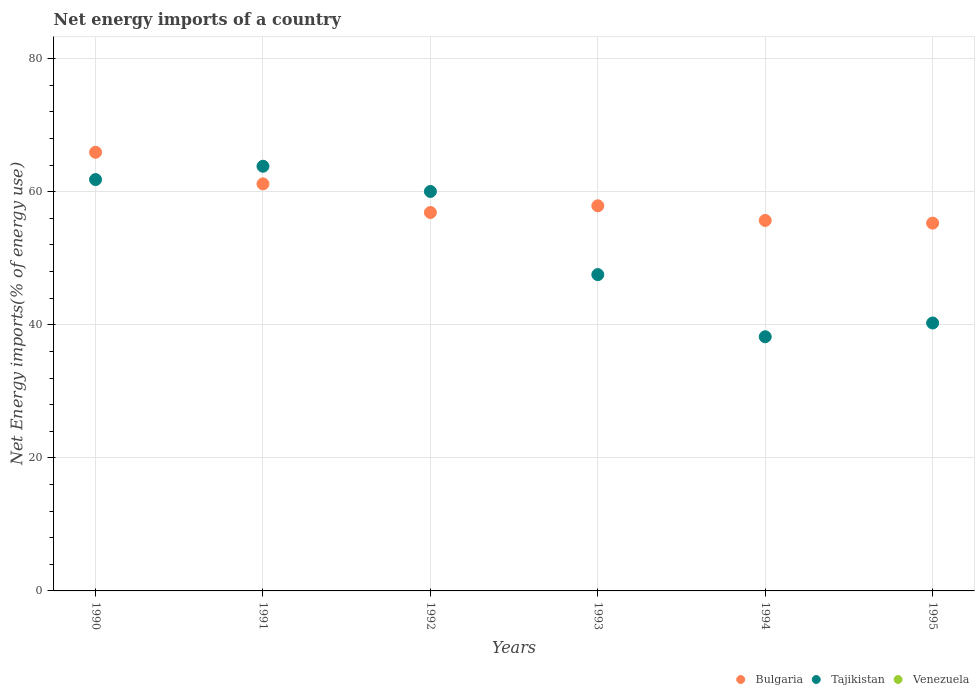How many different coloured dotlines are there?
Keep it short and to the point. 2. Is the number of dotlines equal to the number of legend labels?
Make the answer very short. No. What is the net energy imports in Bulgaria in 1994?
Offer a terse response. 55.69. Across all years, what is the maximum net energy imports in Tajikistan?
Provide a short and direct response. 63.84. Across all years, what is the minimum net energy imports in Bulgaria?
Offer a very short reply. 55.29. In which year was the net energy imports in Bulgaria maximum?
Make the answer very short. 1990. What is the total net energy imports in Tajikistan in the graph?
Provide a succinct answer. 311.75. What is the difference between the net energy imports in Tajikistan in 1992 and that in 1993?
Provide a short and direct response. 12.5. What is the difference between the net energy imports in Tajikistan in 1995 and the net energy imports in Bulgaria in 1990?
Keep it short and to the point. -25.66. What is the average net energy imports in Venezuela per year?
Ensure brevity in your answer.  0. In the year 1993, what is the difference between the net energy imports in Bulgaria and net energy imports in Tajikistan?
Offer a very short reply. 10.34. In how many years, is the net energy imports in Bulgaria greater than 44 %?
Keep it short and to the point. 6. What is the ratio of the net energy imports in Tajikistan in 1990 to that in 1993?
Offer a terse response. 1.3. Is the net energy imports in Tajikistan in 1990 less than that in 1995?
Offer a very short reply. No. What is the difference between the highest and the second highest net energy imports in Bulgaria?
Provide a short and direct response. 4.75. What is the difference between the highest and the lowest net energy imports in Tajikistan?
Your answer should be very brief. 25.63. Is the sum of the net energy imports in Tajikistan in 1991 and 1994 greater than the maximum net energy imports in Bulgaria across all years?
Provide a succinct answer. Yes. Does the net energy imports in Bulgaria monotonically increase over the years?
Provide a short and direct response. No. Is the net energy imports in Bulgaria strictly greater than the net energy imports in Tajikistan over the years?
Offer a terse response. No. How many dotlines are there?
Your answer should be very brief. 2. How many years are there in the graph?
Offer a terse response. 6. What is the difference between two consecutive major ticks on the Y-axis?
Make the answer very short. 20. Are the values on the major ticks of Y-axis written in scientific E-notation?
Give a very brief answer. No. Where does the legend appear in the graph?
Make the answer very short. Bottom right. What is the title of the graph?
Give a very brief answer. Net energy imports of a country. What is the label or title of the Y-axis?
Make the answer very short. Net Energy imports(% of energy use). What is the Net Energy imports(% of energy use) in Bulgaria in 1990?
Provide a succinct answer. 65.94. What is the Net Energy imports(% of energy use) in Tajikistan in 1990?
Offer a terse response. 61.84. What is the Net Energy imports(% of energy use) of Venezuela in 1990?
Give a very brief answer. 0. What is the Net Energy imports(% of energy use) of Bulgaria in 1991?
Provide a succinct answer. 61.19. What is the Net Energy imports(% of energy use) of Tajikistan in 1991?
Provide a short and direct response. 63.84. What is the Net Energy imports(% of energy use) in Bulgaria in 1992?
Provide a short and direct response. 56.88. What is the Net Energy imports(% of energy use) in Tajikistan in 1992?
Provide a succinct answer. 60.05. What is the Net Energy imports(% of energy use) in Bulgaria in 1993?
Ensure brevity in your answer.  57.89. What is the Net Energy imports(% of energy use) of Tajikistan in 1993?
Ensure brevity in your answer.  47.55. What is the Net Energy imports(% of energy use) in Bulgaria in 1994?
Your answer should be very brief. 55.69. What is the Net Energy imports(% of energy use) in Tajikistan in 1994?
Offer a terse response. 38.21. What is the Net Energy imports(% of energy use) of Venezuela in 1994?
Your answer should be very brief. 0. What is the Net Energy imports(% of energy use) of Bulgaria in 1995?
Give a very brief answer. 55.29. What is the Net Energy imports(% of energy use) of Tajikistan in 1995?
Your answer should be very brief. 40.28. Across all years, what is the maximum Net Energy imports(% of energy use) in Bulgaria?
Offer a terse response. 65.94. Across all years, what is the maximum Net Energy imports(% of energy use) of Tajikistan?
Your answer should be compact. 63.84. Across all years, what is the minimum Net Energy imports(% of energy use) of Bulgaria?
Your answer should be compact. 55.29. Across all years, what is the minimum Net Energy imports(% of energy use) in Tajikistan?
Offer a terse response. 38.21. What is the total Net Energy imports(% of energy use) in Bulgaria in the graph?
Offer a terse response. 352.88. What is the total Net Energy imports(% of energy use) of Tajikistan in the graph?
Your answer should be very brief. 311.75. What is the difference between the Net Energy imports(% of energy use) in Bulgaria in 1990 and that in 1991?
Provide a succinct answer. 4.75. What is the difference between the Net Energy imports(% of energy use) in Tajikistan in 1990 and that in 1991?
Your answer should be very brief. -2. What is the difference between the Net Energy imports(% of energy use) of Bulgaria in 1990 and that in 1992?
Ensure brevity in your answer.  9.05. What is the difference between the Net Energy imports(% of energy use) in Tajikistan in 1990 and that in 1992?
Your answer should be very brief. 1.79. What is the difference between the Net Energy imports(% of energy use) of Bulgaria in 1990 and that in 1993?
Make the answer very short. 8.05. What is the difference between the Net Energy imports(% of energy use) in Tajikistan in 1990 and that in 1993?
Your answer should be very brief. 14.29. What is the difference between the Net Energy imports(% of energy use) of Bulgaria in 1990 and that in 1994?
Offer a terse response. 10.25. What is the difference between the Net Energy imports(% of energy use) of Tajikistan in 1990 and that in 1994?
Make the answer very short. 23.63. What is the difference between the Net Energy imports(% of energy use) in Bulgaria in 1990 and that in 1995?
Give a very brief answer. 10.65. What is the difference between the Net Energy imports(% of energy use) in Tajikistan in 1990 and that in 1995?
Offer a very short reply. 21.56. What is the difference between the Net Energy imports(% of energy use) in Bulgaria in 1991 and that in 1992?
Keep it short and to the point. 4.3. What is the difference between the Net Energy imports(% of energy use) of Tajikistan in 1991 and that in 1992?
Your answer should be compact. 3.79. What is the difference between the Net Energy imports(% of energy use) in Bulgaria in 1991 and that in 1993?
Keep it short and to the point. 3.3. What is the difference between the Net Energy imports(% of energy use) in Tajikistan in 1991 and that in 1993?
Provide a succinct answer. 16.29. What is the difference between the Net Energy imports(% of energy use) of Bulgaria in 1991 and that in 1994?
Provide a succinct answer. 5.5. What is the difference between the Net Energy imports(% of energy use) of Tajikistan in 1991 and that in 1994?
Make the answer very short. 25.63. What is the difference between the Net Energy imports(% of energy use) of Bulgaria in 1991 and that in 1995?
Offer a terse response. 5.9. What is the difference between the Net Energy imports(% of energy use) in Tajikistan in 1991 and that in 1995?
Keep it short and to the point. 23.56. What is the difference between the Net Energy imports(% of energy use) in Bulgaria in 1992 and that in 1993?
Your response must be concise. -1.01. What is the difference between the Net Energy imports(% of energy use) of Tajikistan in 1992 and that in 1993?
Give a very brief answer. 12.5. What is the difference between the Net Energy imports(% of energy use) in Bulgaria in 1992 and that in 1994?
Offer a terse response. 1.2. What is the difference between the Net Energy imports(% of energy use) in Tajikistan in 1992 and that in 1994?
Make the answer very short. 21.84. What is the difference between the Net Energy imports(% of energy use) of Bulgaria in 1992 and that in 1995?
Provide a succinct answer. 1.6. What is the difference between the Net Energy imports(% of energy use) in Tajikistan in 1992 and that in 1995?
Your response must be concise. 19.77. What is the difference between the Net Energy imports(% of energy use) of Bulgaria in 1993 and that in 1994?
Offer a terse response. 2.2. What is the difference between the Net Energy imports(% of energy use) in Tajikistan in 1993 and that in 1994?
Your answer should be compact. 9.34. What is the difference between the Net Energy imports(% of energy use) in Bulgaria in 1993 and that in 1995?
Keep it short and to the point. 2.6. What is the difference between the Net Energy imports(% of energy use) of Tajikistan in 1993 and that in 1995?
Make the answer very short. 7.27. What is the difference between the Net Energy imports(% of energy use) in Bulgaria in 1994 and that in 1995?
Your answer should be very brief. 0.4. What is the difference between the Net Energy imports(% of energy use) of Tajikistan in 1994 and that in 1995?
Offer a terse response. -2.07. What is the difference between the Net Energy imports(% of energy use) in Bulgaria in 1990 and the Net Energy imports(% of energy use) in Tajikistan in 1991?
Your answer should be very brief. 2.1. What is the difference between the Net Energy imports(% of energy use) in Bulgaria in 1990 and the Net Energy imports(% of energy use) in Tajikistan in 1992?
Keep it short and to the point. 5.89. What is the difference between the Net Energy imports(% of energy use) of Bulgaria in 1990 and the Net Energy imports(% of energy use) of Tajikistan in 1993?
Provide a succinct answer. 18.39. What is the difference between the Net Energy imports(% of energy use) of Bulgaria in 1990 and the Net Energy imports(% of energy use) of Tajikistan in 1994?
Your answer should be very brief. 27.73. What is the difference between the Net Energy imports(% of energy use) in Bulgaria in 1990 and the Net Energy imports(% of energy use) in Tajikistan in 1995?
Provide a short and direct response. 25.66. What is the difference between the Net Energy imports(% of energy use) in Bulgaria in 1991 and the Net Energy imports(% of energy use) in Tajikistan in 1992?
Keep it short and to the point. 1.14. What is the difference between the Net Energy imports(% of energy use) in Bulgaria in 1991 and the Net Energy imports(% of energy use) in Tajikistan in 1993?
Your response must be concise. 13.64. What is the difference between the Net Energy imports(% of energy use) in Bulgaria in 1991 and the Net Energy imports(% of energy use) in Tajikistan in 1994?
Your answer should be compact. 22.98. What is the difference between the Net Energy imports(% of energy use) of Bulgaria in 1991 and the Net Energy imports(% of energy use) of Tajikistan in 1995?
Ensure brevity in your answer.  20.91. What is the difference between the Net Energy imports(% of energy use) in Bulgaria in 1992 and the Net Energy imports(% of energy use) in Tajikistan in 1993?
Your answer should be compact. 9.34. What is the difference between the Net Energy imports(% of energy use) of Bulgaria in 1992 and the Net Energy imports(% of energy use) of Tajikistan in 1994?
Provide a short and direct response. 18.68. What is the difference between the Net Energy imports(% of energy use) of Bulgaria in 1992 and the Net Energy imports(% of energy use) of Tajikistan in 1995?
Provide a succinct answer. 16.61. What is the difference between the Net Energy imports(% of energy use) in Bulgaria in 1993 and the Net Energy imports(% of energy use) in Tajikistan in 1994?
Your answer should be compact. 19.68. What is the difference between the Net Energy imports(% of energy use) of Bulgaria in 1993 and the Net Energy imports(% of energy use) of Tajikistan in 1995?
Provide a succinct answer. 17.61. What is the difference between the Net Energy imports(% of energy use) in Bulgaria in 1994 and the Net Energy imports(% of energy use) in Tajikistan in 1995?
Keep it short and to the point. 15.41. What is the average Net Energy imports(% of energy use) in Bulgaria per year?
Provide a succinct answer. 58.81. What is the average Net Energy imports(% of energy use) in Tajikistan per year?
Give a very brief answer. 51.96. What is the average Net Energy imports(% of energy use) in Venezuela per year?
Offer a terse response. 0. In the year 1990, what is the difference between the Net Energy imports(% of energy use) of Bulgaria and Net Energy imports(% of energy use) of Tajikistan?
Offer a very short reply. 4.1. In the year 1991, what is the difference between the Net Energy imports(% of energy use) in Bulgaria and Net Energy imports(% of energy use) in Tajikistan?
Offer a very short reply. -2.65. In the year 1992, what is the difference between the Net Energy imports(% of energy use) in Bulgaria and Net Energy imports(% of energy use) in Tajikistan?
Your answer should be very brief. -3.16. In the year 1993, what is the difference between the Net Energy imports(% of energy use) in Bulgaria and Net Energy imports(% of energy use) in Tajikistan?
Offer a very short reply. 10.34. In the year 1994, what is the difference between the Net Energy imports(% of energy use) of Bulgaria and Net Energy imports(% of energy use) of Tajikistan?
Ensure brevity in your answer.  17.48. In the year 1995, what is the difference between the Net Energy imports(% of energy use) of Bulgaria and Net Energy imports(% of energy use) of Tajikistan?
Your response must be concise. 15.01. What is the ratio of the Net Energy imports(% of energy use) in Bulgaria in 1990 to that in 1991?
Make the answer very short. 1.08. What is the ratio of the Net Energy imports(% of energy use) of Tajikistan in 1990 to that in 1991?
Make the answer very short. 0.97. What is the ratio of the Net Energy imports(% of energy use) of Bulgaria in 1990 to that in 1992?
Keep it short and to the point. 1.16. What is the ratio of the Net Energy imports(% of energy use) of Tajikistan in 1990 to that in 1992?
Keep it short and to the point. 1.03. What is the ratio of the Net Energy imports(% of energy use) of Bulgaria in 1990 to that in 1993?
Offer a terse response. 1.14. What is the ratio of the Net Energy imports(% of energy use) in Tajikistan in 1990 to that in 1993?
Your answer should be compact. 1.3. What is the ratio of the Net Energy imports(% of energy use) in Bulgaria in 1990 to that in 1994?
Give a very brief answer. 1.18. What is the ratio of the Net Energy imports(% of energy use) in Tajikistan in 1990 to that in 1994?
Provide a succinct answer. 1.62. What is the ratio of the Net Energy imports(% of energy use) of Bulgaria in 1990 to that in 1995?
Your response must be concise. 1.19. What is the ratio of the Net Energy imports(% of energy use) of Tajikistan in 1990 to that in 1995?
Your response must be concise. 1.54. What is the ratio of the Net Energy imports(% of energy use) in Bulgaria in 1991 to that in 1992?
Provide a succinct answer. 1.08. What is the ratio of the Net Energy imports(% of energy use) of Tajikistan in 1991 to that in 1992?
Ensure brevity in your answer.  1.06. What is the ratio of the Net Energy imports(% of energy use) of Bulgaria in 1991 to that in 1993?
Ensure brevity in your answer.  1.06. What is the ratio of the Net Energy imports(% of energy use) of Tajikistan in 1991 to that in 1993?
Your response must be concise. 1.34. What is the ratio of the Net Energy imports(% of energy use) of Bulgaria in 1991 to that in 1994?
Offer a terse response. 1.1. What is the ratio of the Net Energy imports(% of energy use) of Tajikistan in 1991 to that in 1994?
Ensure brevity in your answer.  1.67. What is the ratio of the Net Energy imports(% of energy use) in Bulgaria in 1991 to that in 1995?
Keep it short and to the point. 1.11. What is the ratio of the Net Energy imports(% of energy use) of Tajikistan in 1991 to that in 1995?
Make the answer very short. 1.58. What is the ratio of the Net Energy imports(% of energy use) in Bulgaria in 1992 to that in 1993?
Make the answer very short. 0.98. What is the ratio of the Net Energy imports(% of energy use) of Tajikistan in 1992 to that in 1993?
Make the answer very short. 1.26. What is the ratio of the Net Energy imports(% of energy use) of Bulgaria in 1992 to that in 1994?
Keep it short and to the point. 1.02. What is the ratio of the Net Energy imports(% of energy use) of Tajikistan in 1992 to that in 1994?
Keep it short and to the point. 1.57. What is the ratio of the Net Energy imports(% of energy use) of Bulgaria in 1992 to that in 1995?
Ensure brevity in your answer.  1.03. What is the ratio of the Net Energy imports(% of energy use) in Tajikistan in 1992 to that in 1995?
Offer a very short reply. 1.49. What is the ratio of the Net Energy imports(% of energy use) of Bulgaria in 1993 to that in 1994?
Your answer should be compact. 1.04. What is the ratio of the Net Energy imports(% of energy use) of Tajikistan in 1993 to that in 1994?
Make the answer very short. 1.24. What is the ratio of the Net Energy imports(% of energy use) in Bulgaria in 1993 to that in 1995?
Provide a short and direct response. 1.05. What is the ratio of the Net Energy imports(% of energy use) of Tajikistan in 1993 to that in 1995?
Give a very brief answer. 1.18. What is the ratio of the Net Energy imports(% of energy use) of Bulgaria in 1994 to that in 1995?
Your response must be concise. 1.01. What is the ratio of the Net Energy imports(% of energy use) of Tajikistan in 1994 to that in 1995?
Give a very brief answer. 0.95. What is the difference between the highest and the second highest Net Energy imports(% of energy use) of Bulgaria?
Provide a short and direct response. 4.75. What is the difference between the highest and the second highest Net Energy imports(% of energy use) of Tajikistan?
Provide a succinct answer. 2. What is the difference between the highest and the lowest Net Energy imports(% of energy use) in Bulgaria?
Offer a terse response. 10.65. What is the difference between the highest and the lowest Net Energy imports(% of energy use) of Tajikistan?
Provide a succinct answer. 25.63. 